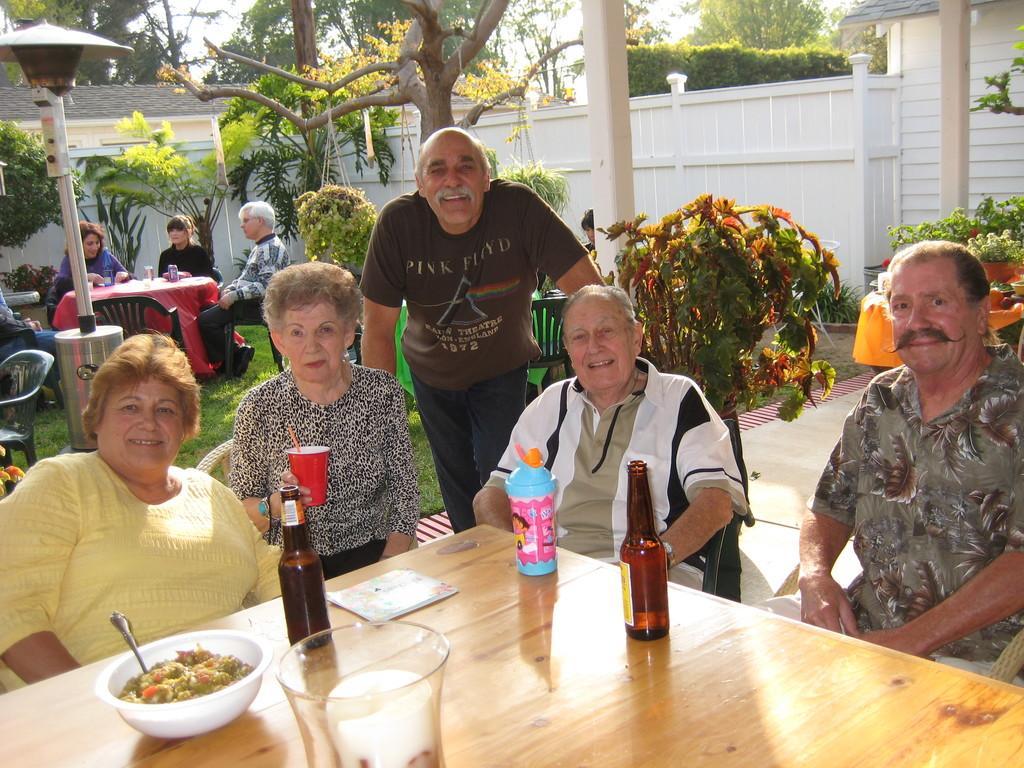Can you describe this image briefly? people are seated on the chairs around the table. on the table there is a glass, glass bottles, bowl of food. a person is holding a red glass. behind them a person is standing. behind them are more tables and chairs on which people are seated on the grass. there are many trees and a wall is surrounded by that. behind that there are trees and building. 